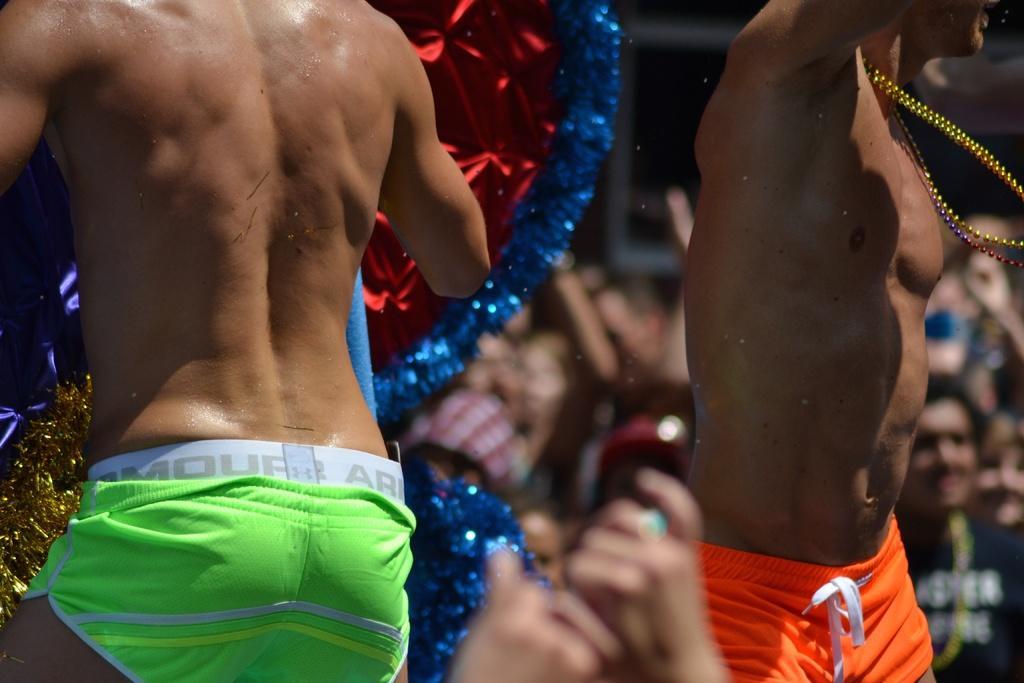How would you summarize this image in a sentence or two? In this image I see 2 men who are wearing shorts which are of green and orange in color and I see the red, blue and golden color thing in the background and I see few more people and I see that it is blurred in the background. 